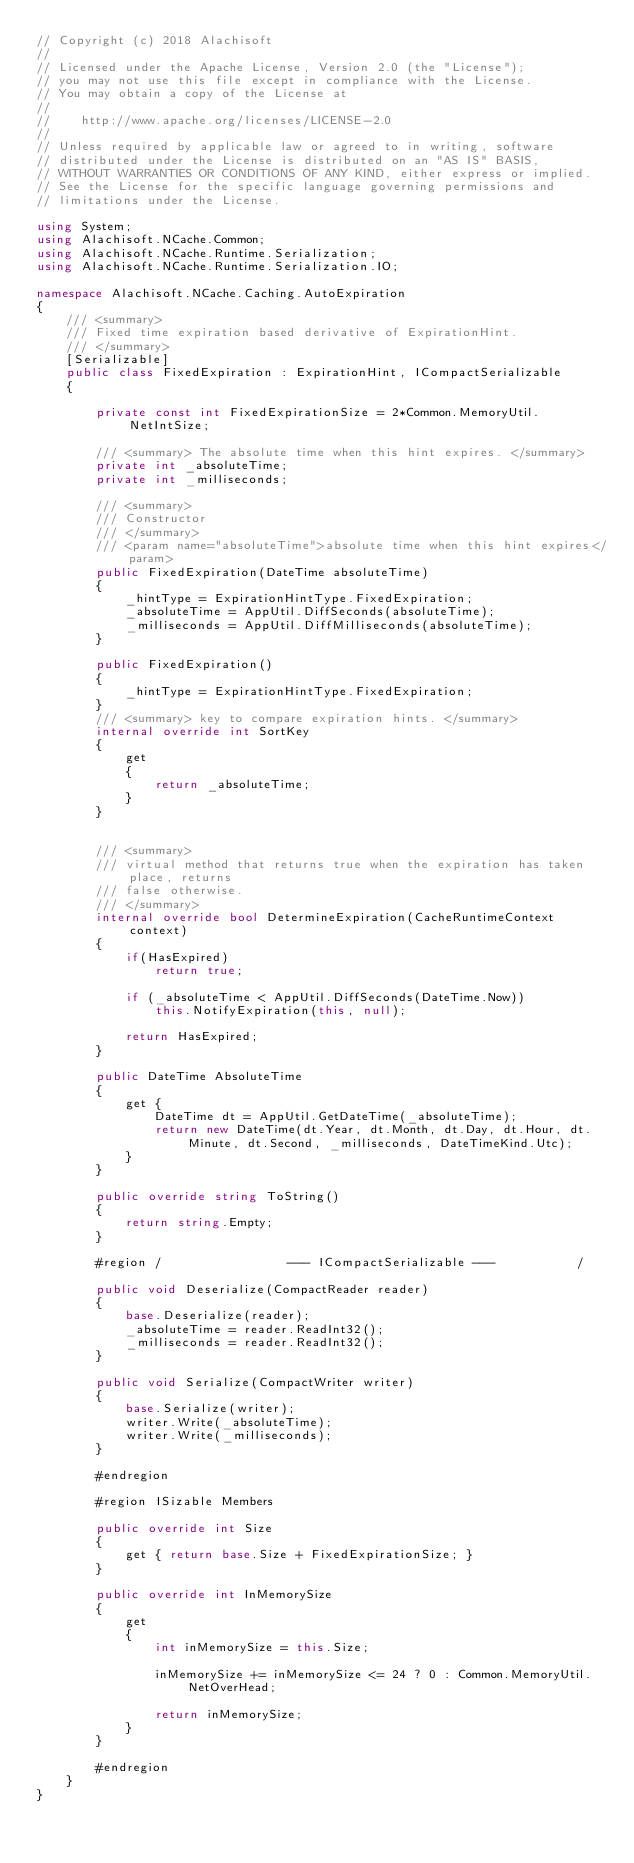Convert code to text. <code><loc_0><loc_0><loc_500><loc_500><_C#_>// Copyright (c) 2018 Alachisoft
// 
// Licensed under the Apache License, Version 2.0 (the "License");
// you may not use this file except in compliance with the License.
// You may obtain a copy of the License at
// 
//    http://www.apache.org/licenses/LICENSE-2.0
// 
// Unless required by applicable law or agreed to in writing, software
// distributed under the License is distributed on an "AS IS" BASIS,
// WITHOUT WARRANTIES OR CONDITIONS OF ANY KIND, either express or implied.
// See the License for the specific language governing permissions and
// limitations under the License.

using System;
using Alachisoft.NCache.Common;
using Alachisoft.NCache.Runtime.Serialization;
using Alachisoft.NCache.Runtime.Serialization.IO;

namespace Alachisoft.NCache.Caching.AutoExpiration
{
	/// <summary>
	/// Fixed time expiration based derivative of ExpirationHint.
	/// </summary>
	[Serializable]
	public class FixedExpiration : ExpirationHint, ICompactSerializable
	{

        private const int FixedExpirationSize = 2*Common.MemoryUtil.NetIntSize;

        /// <summary> The absolute time when this hint expires. </summary>
		private int _absoluteTime;
        private int _milliseconds;

		/// <summary>
		/// Constructor
		/// </summary>
		/// <param name="absoluteTime">absolute time when this hint expires</param>
		public FixedExpiration(DateTime absoluteTime)
		{
            _hintType = ExpirationHintType.FixedExpiration;
            _absoluteTime = AppUtil.DiffSeconds(absoluteTime);
            _milliseconds = AppUtil.DiffMilliseconds(absoluteTime);
		}

        public FixedExpiration()
        {
            _hintType = ExpirationHintType.FixedExpiration;            
        }
        /// <summary> key to compare expiration hints. </summary>
		internal override int SortKey
		{
			get
			{
				return _absoluteTime;
			}
		}


		/// <summary>
		/// virtual method that returns true when the expiration has taken place, returns 
		/// false otherwise.
		/// </summary>
		internal override bool DetermineExpiration(CacheRuntimeContext context)
		{ 
			if(HasExpired) 
				return true;

            if (_absoluteTime < AppUtil.DiffSeconds(DateTime.Now))
                this.NotifyExpiration(this, null);

			return HasExpired;
		}

        public DateTime AbsoluteTime
        {
            get { 
                DateTime dt = AppUtil.GetDateTime(_absoluteTime);
                return new DateTime(dt.Year, dt.Month, dt.Day, dt.Hour, dt.Minute, dt.Second, _milliseconds, DateTimeKind.Utc);
            }
        }

        public override string ToString()
        {
            return string.Empty;
        }

		#region	/                 --- ICompactSerializable ---           /

		public void Deserialize(CompactReader reader)
		{
            base.Deserialize(reader);
			_absoluteTime = reader.ReadInt32();
            _milliseconds = reader.ReadInt32();
		}

		public void Serialize(CompactWriter writer)
		{
            base.Serialize(writer);
			writer.Write(_absoluteTime);
            writer.Write(_milliseconds);
		}

		#endregion

        #region ISizable Members

        public override int Size
        {
            get { return base.Size + FixedExpirationSize; }
        }

        public override int InMemorySize
        {
            get
            {
                int inMemorySize = this.Size;

                inMemorySize += inMemorySize <= 24 ? 0 : Common.MemoryUtil.NetOverHead;

                return inMemorySize;
            }
        }      

        #endregion
    }
}
</code> 